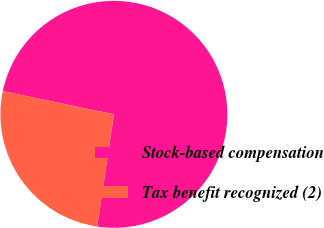Convert chart. <chart><loc_0><loc_0><loc_500><loc_500><pie_chart><fcel>Stock-based compensation<fcel>Tax benefit recognized (2)<nl><fcel>74.07%<fcel>25.93%<nl></chart> 